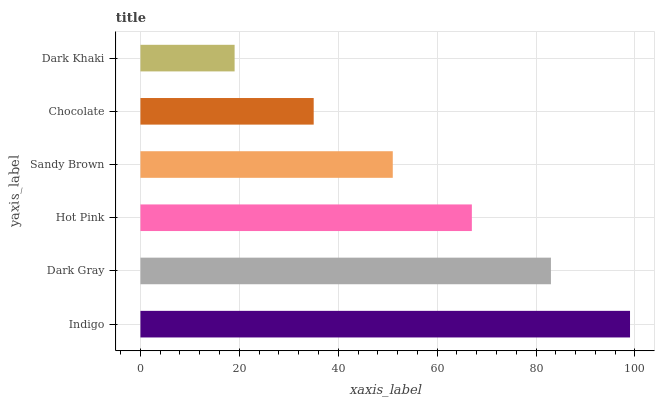Is Dark Khaki the minimum?
Answer yes or no. Yes. Is Indigo the maximum?
Answer yes or no. Yes. Is Dark Gray the minimum?
Answer yes or no. No. Is Dark Gray the maximum?
Answer yes or no. No. Is Indigo greater than Dark Gray?
Answer yes or no. Yes. Is Dark Gray less than Indigo?
Answer yes or no. Yes. Is Dark Gray greater than Indigo?
Answer yes or no. No. Is Indigo less than Dark Gray?
Answer yes or no. No. Is Hot Pink the high median?
Answer yes or no. Yes. Is Sandy Brown the low median?
Answer yes or no. Yes. Is Indigo the high median?
Answer yes or no. No. Is Dark Gray the low median?
Answer yes or no. No. 